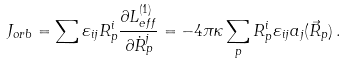<formula> <loc_0><loc_0><loc_500><loc_500>J _ { o r b } = \sum \varepsilon _ { i j } R ^ { i } _ { p } \frac { \partial L ^ { ( 1 ) } _ { e f f } } { \partial \dot { R } ^ { j } _ { p } } = - 4 \pi \kappa \sum _ { p } R ^ { i } _ { p } \varepsilon _ { i j } a _ { j } ( \vec { R } _ { p } ) \, .</formula> 